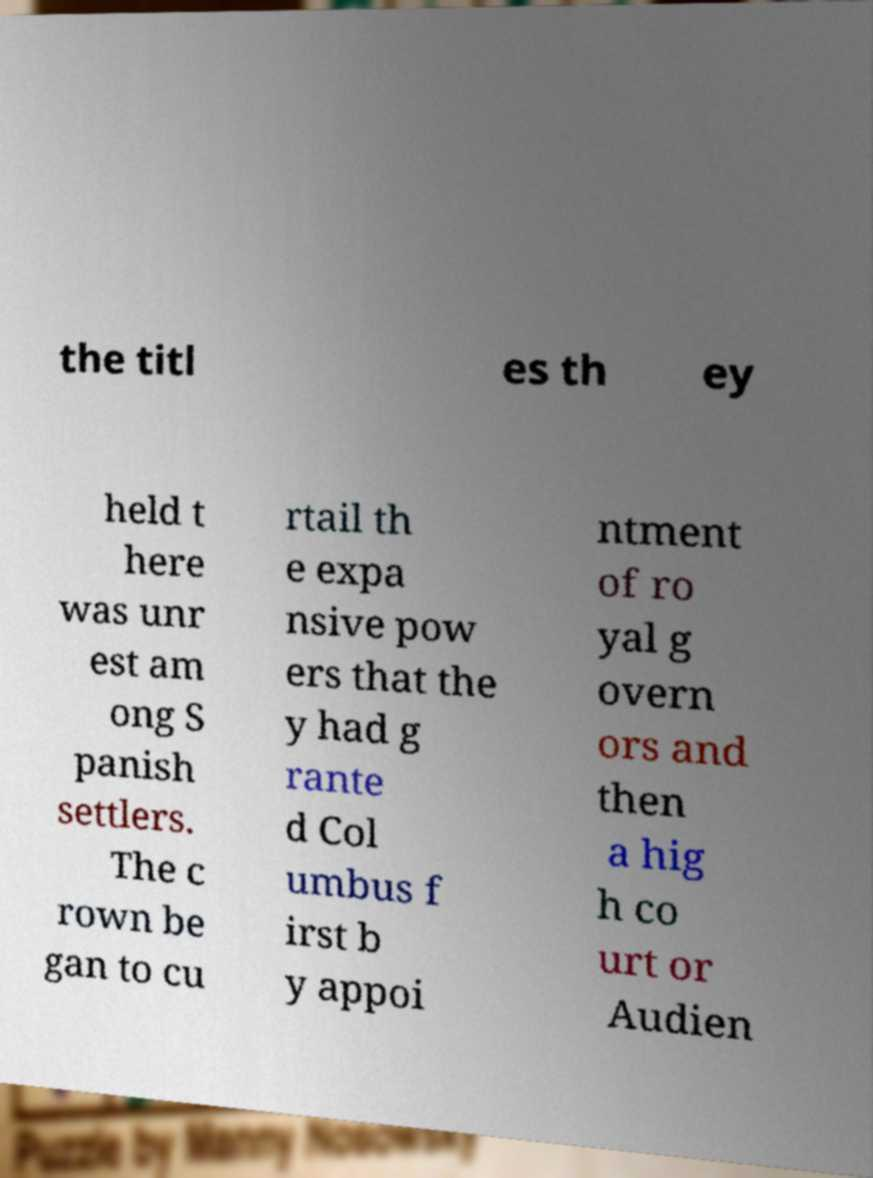Could you assist in decoding the text presented in this image and type it out clearly? the titl es th ey held t here was unr est am ong S panish settlers. The c rown be gan to cu rtail th e expa nsive pow ers that the y had g rante d Col umbus f irst b y appoi ntment of ro yal g overn ors and then a hig h co urt or Audien 